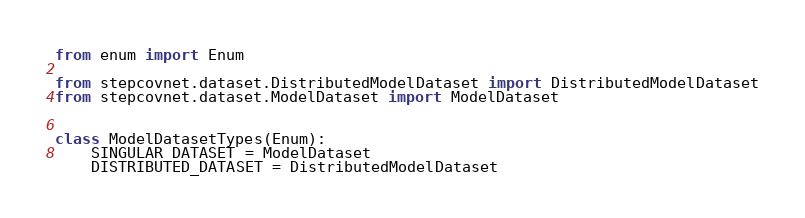<code> <loc_0><loc_0><loc_500><loc_500><_Python_>from enum import Enum

from stepcovnet.dataset.DistributedModelDataset import DistributedModelDataset
from stepcovnet.dataset.ModelDataset import ModelDataset


class ModelDatasetTypes(Enum):
    SINGULAR_DATASET = ModelDataset
    DISTRIBUTED_DATASET = DistributedModelDataset
</code> 